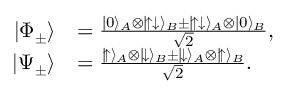<formula> <loc_0><loc_0><loc_500><loc_500>\begin{array} { r l } { | \Phi _ { \pm } \rangle } & { = \frac { | 0 \rangle _ { A } \otimes | \, \uparrow \downarrow \rangle _ { B } \pm | \, \uparrow \downarrow \rangle _ { A } \otimes | 0 \rangle _ { B } } { \sqrt { 2 } } , } \\ { | \Psi _ { \pm } \rangle } & { = \frac { | \, \uparrow \rangle _ { A } \otimes | \, \downarrow \rangle _ { B } \pm | \, \downarrow \rangle _ { A } \otimes | \, \uparrow \rangle _ { B } } { \sqrt { 2 } } . } \end{array}</formula> 